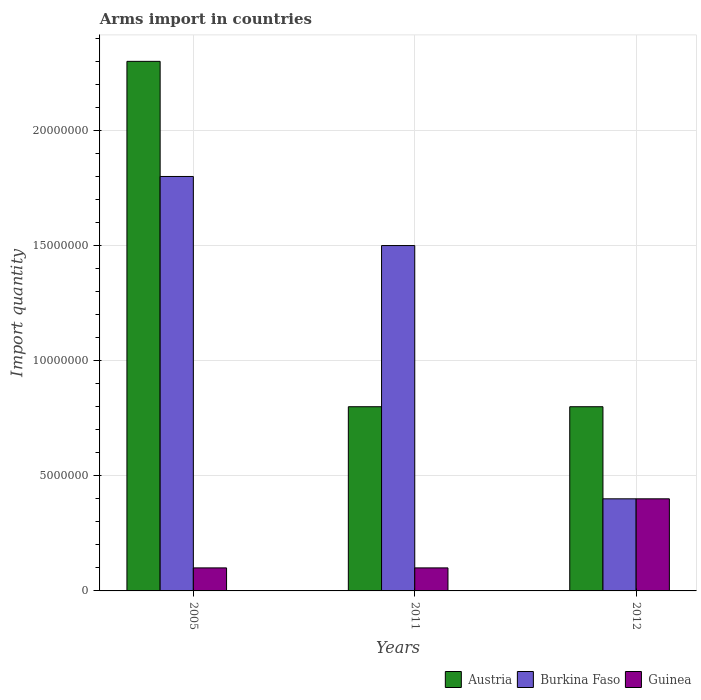How many groups of bars are there?
Your answer should be very brief. 3. Are the number of bars per tick equal to the number of legend labels?
Make the answer very short. Yes. How many bars are there on the 3rd tick from the left?
Your answer should be compact. 3. How many bars are there on the 2nd tick from the right?
Make the answer very short. 3. In how many cases, is the number of bars for a given year not equal to the number of legend labels?
Provide a succinct answer. 0. What is the total arms import in Guinea in 2005?
Your answer should be compact. 1.00e+06. Across all years, what is the maximum total arms import in Burkina Faso?
Keep it short and to the point. 1.80e+07. Across all years, what is the minimum total arms import in Burkina Faso?
Your answer should be compact. 4.00e+06. In which year was the total arms import in Austria maximum?
Make the answer very short. 2005. What is the total total arms import in Austria in the graph?
Your response must be concise. 3.90e+07. What is the difference between the total arms import in Burkina Faso in 2005 and that in 2012?
Your response must be concise. 1.40e+07. What is the difference between the total arms import in Burkina Faso in 2011 and the total arms import in Austria in 2005?
Your answer should be very brief. -8.00e+06. What is the average total arms import in Guinea per year?
Provide a succinct answer. 2.00e+06. In the year 2011, what is the difference between the total arms import in Burkina Faso and total arms import in Guinea?
Ensure brevity in your answer.  1.40e+07. In how many years, is the total arms import in Austria greater than 1000000?
Offer a very short reply. 3. Is the difference between the total arms import in Burkina Faso in 2005 and 2011 greater than the difference between the total arms import in Guinea in 2005 and 2011?
Your response must be concise. Yes. What is the difference between the highest and the second highest total arms import in Burkina Faso?
Your answer should be very brief. 3.00e+06. What is the difference between the highest and the lowest total arms import in Burkina Faso?
Offer a very short reply. 1.40e+07. What does the 2nd bar from the left in 2005 represents?
Make the answer very short. Burkina Faso. What does the 1st bar from the right in 2012 represents?
Provide a short and direct response. Guinea. Are all the bars in the graph horizontal?
Keep it short and to the point. No. How many years are there in the graph?
Ensure brevity in your answer.  3. Does the graph contain grids?
Provide a short and direct response. Yes. How many legend labels are there?
Provide a short and direct response. 3. What is the title of the graph?
Offer a very short reply. Arms import in countries. Does "Mauritania" appear as one of the legend labels in the graph?
Make the answer very short. No. What is the label or title of the Y-axis?
Provide a succinct answer. Import quantity. What is the Import quantity of Austria in 2005?
Your answer should be very brief. 2.30e+07. What is the Import quantity of Burkina Faso in 2005?
Provide a short and direct response. 1.80e+07. What is the Import quantity of Burkina Faso in 2011?
Provide a short and direct response. 1.50e+07. What is the Import quantity of Guinea in 2012?
Offer a very short reply. 4.00e+06. Across all years, what is the maximum Import quantity in Austria?
Your answer should be very brief. 2.30e+07. Across all years, what is the maximum Import quantity of Burkina Faso?
Keep it short and to the point. 1.80e+07. Across all years, what is the maximum Import quantity in Guinea?
Keep it short and to the point. 4.00e+06. Across all years, what is the minimum Import quantity of Austria?
Provide a succinct answer. 8.00e+06. Across all years, what is the minimum Import quantity of Burkina Faso?
Provide a succinct answer. 4.00e+06. Across all years, what is the minimum Import quantity in Guinea?
Provide a succinct answer. 1.00e+06. What is the total Import quantity in Austria in the graph?
Your response must be concise. 3.90e+07. What is the total Import quantity of Burkina Faso in the graph?
Offer a very short reply. 3.70e+07. What is the total Import quantity of Guinea in the graph?
Your response must be concise. 6.00e+06. What is the difference between the Import quantity in Austria in 2005 and that in 2011?
Keep it short and to the point. 1.50e+07. What is the difference between the Import quantity of Burkina Faso in 2005 and that in 2011?
Give a very brief answer. 3.00e+06. What is the difference between the Import quantity in Guinea in 2005 and that in 2011?
Offer a terse response. 0. What is the difference between the Import quantity of Austria in 2005 and that in 2012?
Offer a terse response. 1.50e+07. What is the difference between the Import quantity of Burkina Faso in 2005 and that in 2012?
Keep it short and to the point. 1.40e+07. What is the difference between the Import quantity of Guinea in 2005 and that in 2012?
Provide a succinct answer. -3.00e+06. What is the difference between the Import quantity in Burkina Faso in 2011 and that in 2012?
Your response must be concise. 1.10e+07. What is the difference between the Import quantity of Guinea in 2011 and that in 2012?
Your answer should be compact. -3.00e+06. What is the difference between the Import quantity of Austria in 2005 and the Import quantity of Burkina Faso in 2011?
Your answer should be compact. 8.00e+06. What is the difference between the Import quantity in Austria in 2005 and the Import quantity in Guinea in 2011?
Your response must be concise. 2.20e+07. What is the difference between the Import quantity of Burkina Faso in 2005 and the Import quantity of Guinea in 2011?
Ensure brevity in your answer.  1.70e+07. What is the difference between the Import quantity in Austria in 2005 and the Import quantity in Burkina Faso in 2012?
Offer a very short reply. 1.90e+07. What is the difference between the Import quantity in Austria in 2005 and the Import quantity in Guinea in 2012?
Keep it short and to the point. 1.90e+07. What is the difference between the Import quantity of Burkina Faso in 2005 and the Import quantity of Guinea in 2012?
Your answer should be compact. 1.40e+07. What is the difference between the Import quantity in Austria in 2011 and the Import quantity in Guinea in 2012?
Make the answer very short. 4.00e+06. What is the difference between the Import quantity of Burkina Faso in 2011 and the Import quantity of Guinea in 2012?
Offer a terse response. 1.10e+07. What is the average Import quantity in Austria per year?
Offer a very short reply. 1.30e+07. What is the average Import quantity in Burkina Faso per year?
Your answer should be compact. 1.23e+07. What is the average Import quantity in Guinea per year?
Your answer should be very brief. 2.00e+06. In the year 2005, what is the difference between the Import quantity of Austria and Import quantity of Burkina Faso?
Keep it short and to the point. 5.00e+06. In the year 2005, what is the difference between the Import quantity of Austria and Import quantity of Guinea?
Offer a terse response. 2.20e+07. In the year 2005, what is the difference between the Import quantity of Burkina Faso and Import quantity of Guinea?
Provide a succinct answer. 1.70e+07. In the year 2011, what is the difference between the Import quantity in Austria and Import quantity in Burkina Faso?
Give a very brief answer. -7.00e+06. In the year 2011, what is the difference between the Import quantity in Burkina Faso and Import quantity in Guinea?
Provide a short and direct response. 1.40e+07. What is the ratio of the Import quantity of Austria in 2005 to that in 2011?
Give a very brief answer. 2.88. What is the ratio of the Import quantity in Guinea in 2005 to that in 2011?
Your answer should be compact. 1. What is the ratio of the Import quantity in Austria in 2005 to that in 2012?
Provide a short and direct response. 2.88. What is the ratio of the Import quantity of Guinea in 2005 to that in 2012?
Make the answer very short. 0.25. What is the ratio of the Import quantity in Austria in 2011 to that in 2012?
Ensure brevity in your answer.  1. What is the ratio of the Import quantity in Burkina Faso in 2011 to that in 2012?
Ensure brevity in your answer.  3.75. What is the difference between the highest and the second highest Import quantity in Austria?
Keep it short and to the point. 1.50e+07. What is the difference between the highest and the lowest Import quantity of Austria?
Give a very brief answer. 1.50e+07. What is the difference between the highest and the lowest Import quantity in Burkina Faso?
Offer a very short reply. 1.40e+07. What is the difference between the highest and the lowest Import quantity of Guinea?
Offer a terse response. 3.00e+06. 